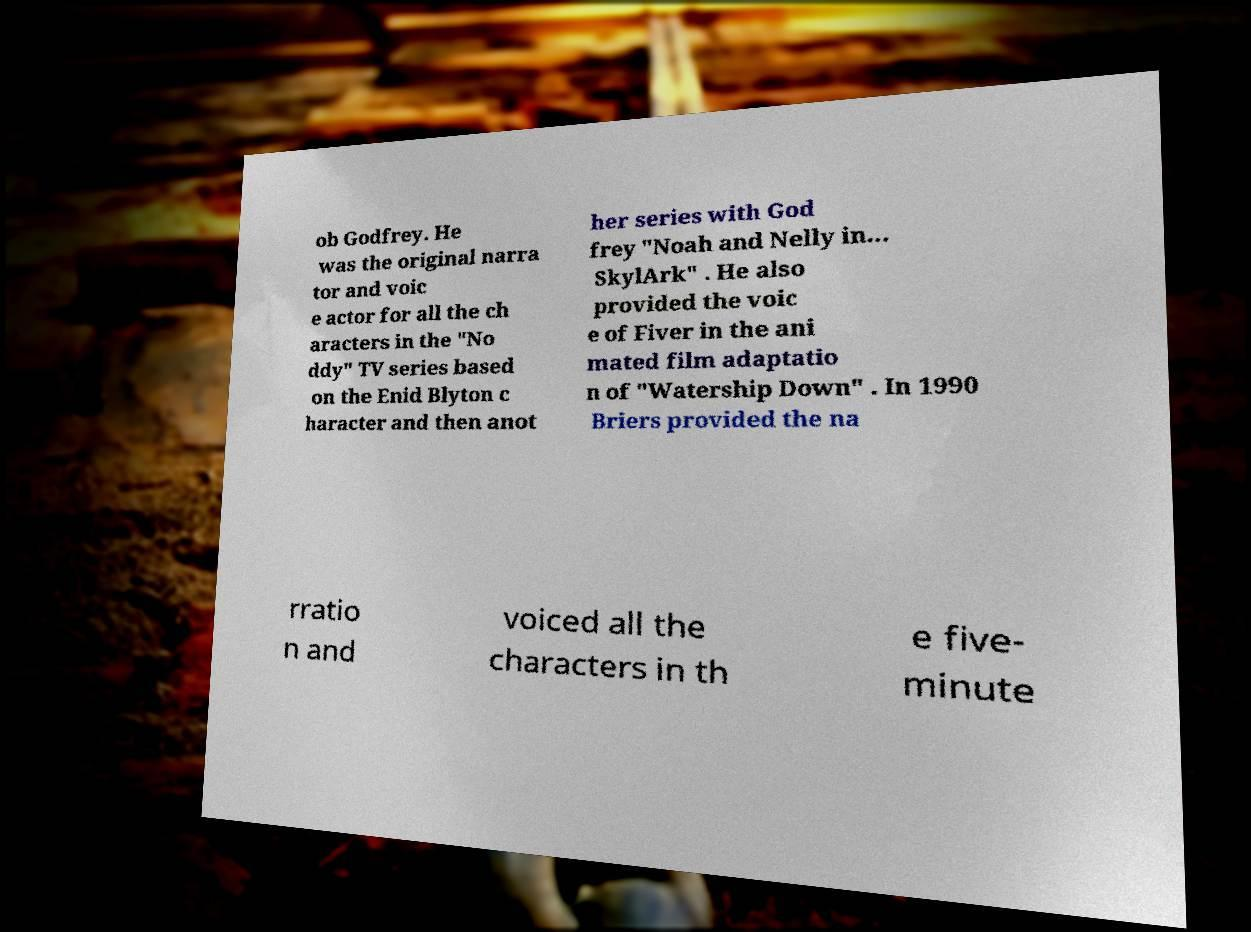Please read and relay the text visible in this image. What does it say? ob Godfrey. He was the original narra tor and voic e actor for all the ch aracters in the "No ddy" TV series based on the Enid Blyton c haracter and then anot her series with God frey "Noah and Nelly in... SkylArk" . He also provided the voic e of Fiver in the ani mated film adaptatio n of "Watership Down" . In 1990 Briers provided the na rratio n and voiced all the characters in th e five- minute 